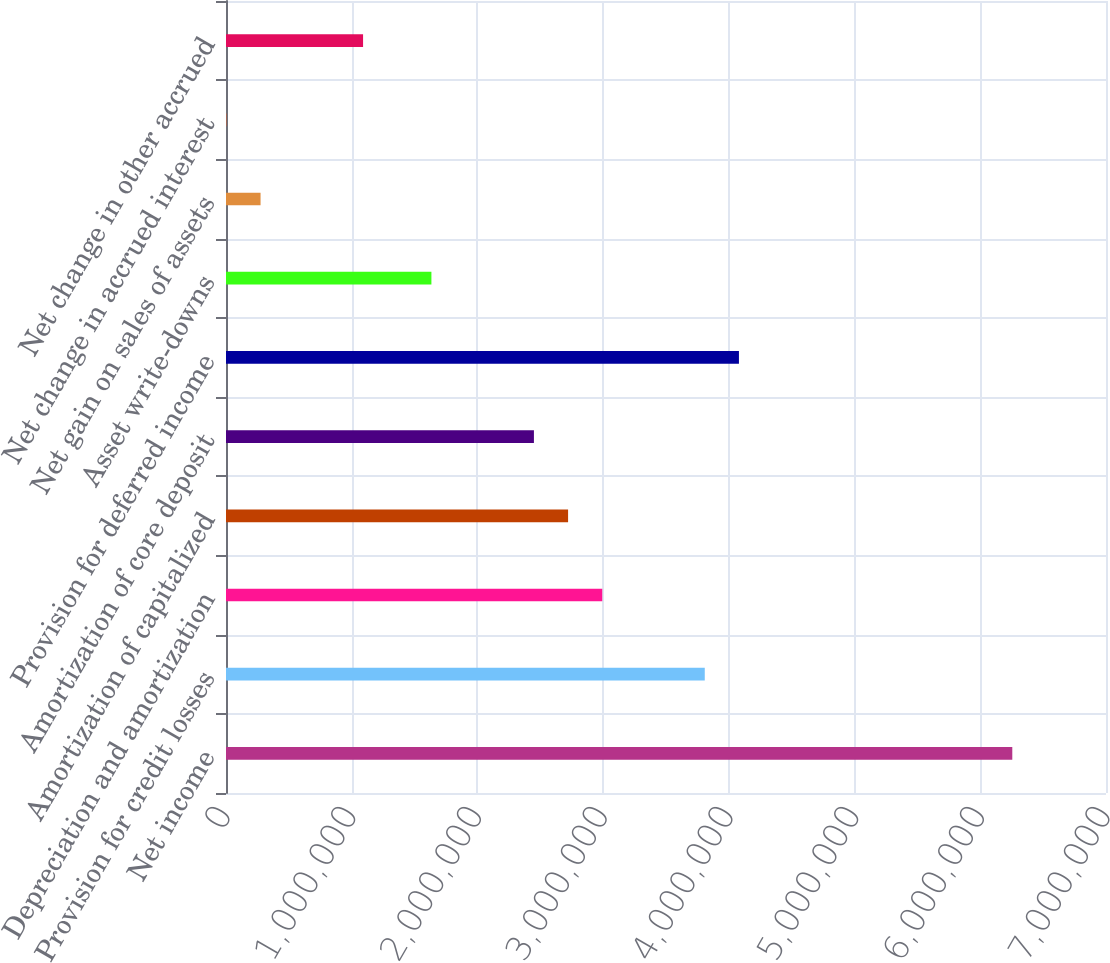<chart> <loc_0><loc_0><loc_500><loc_500><bar_chart><fcel>Net income<fcel>Provision for credit losses<fcel>Depreciation and amortization<fcel>Amortization of capitalized<fcel>Amortization of core deposit<fcel>Provision for deferred income<fcel>Asset write-downs<fcel>Net gain on sales of assets<fcel>Net change in accrued interest<fcel>Net change in other accrued<nl><fcel>6.25463e+06<fcel>3.80838e+06<fcel>2.99296e+06<fcel>2.72116e+06<fcel>2.44935e+06<fcel>4.08018e+06<fcel>1.63393e+06<fcel>274905<fcel>3099<fcel>1.09032e+06<nl></chart> 